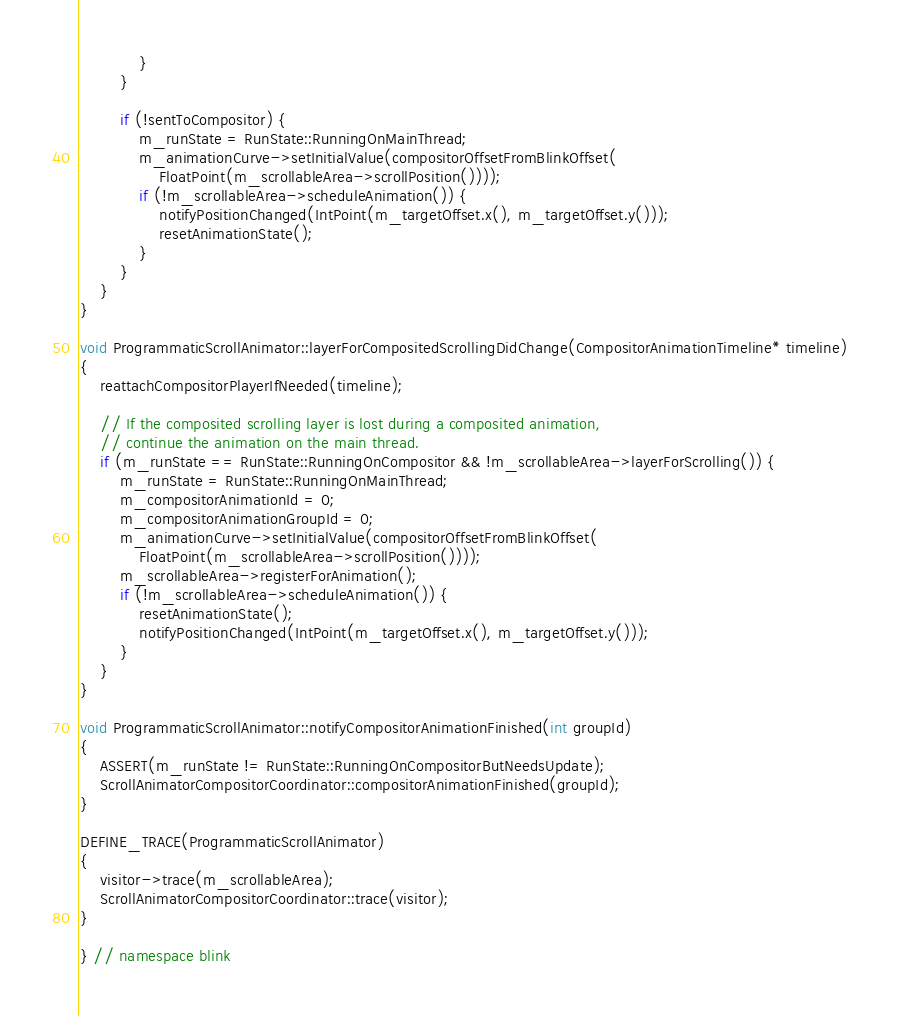<code> <loc_0><loc_0><loc_500><loc_500><_C++_>            }
        }

        if (!sentToCompositor) {
            m_runState = RunState::RunningOnMainThread;
            m_animationCurve->setInitialValue(compositorOffsetFromBlinkOffset(
                FloatPoint(m_scrollableArea->scrollPosition())));
            if (!m_scrollableArea->scheduleAnimation()) {
                notifyPositionChanged(IntPoint(m_targetOffset.x(), m_targetOffset.y()));
                resetAnimationState();
            }
        }
    }
}

void ProgrammaticScrollAnimator::layerForCompositedScrollingDidChange(CompositorAnimationTimeline* timeline)
{
    reattachCompositorPlayerIfNeeded(timeline);

    // If the composited scrolling layer is lost during a composited animation,
    // continue the animation on the main thread.
    if (m_runState == RunState::RunningOnCompositor && !m_scrollableArea->layerForScrolling()) {
        m_runState = RunState::RunningOnMainThread;
        m_compositorAnimationId = 0;
        m_compositorAnimationGroupId = 0;
        m_animationCurve->setInitialValue(compositorOffsetFromBlinkOffset(
            FloatPoint(m_scrollableArea->scrollPosition())));
        m_scrollableArea->registerForAnimation();
        if (!m_scrollableArea->scheduleAnimation()) {
            resetAnimationState();
            notifyPositionChanged(IntPoint(m_targetOffset.x(), m_targetOffset.y()));
        }
    }
}

void ProgrammaticScrollAnimator::notifyCompositorAnimationFinished(int groupId)
{
    ASSERT(m_runState != RunState::RunningOnCompositorButNeedsUpdate);
    ScrollAnimatorCompositorCoordinator::compositorAnimationFinished(groupId);
}

DEFINE_TRACE(ProgrammaticScrollAnimator)
{
    visitor->trace(m_scrollableArea);
    ScrollAnimatorCompositorCoordinator::trace(visitor);
}

} // namespace blink
</code> 